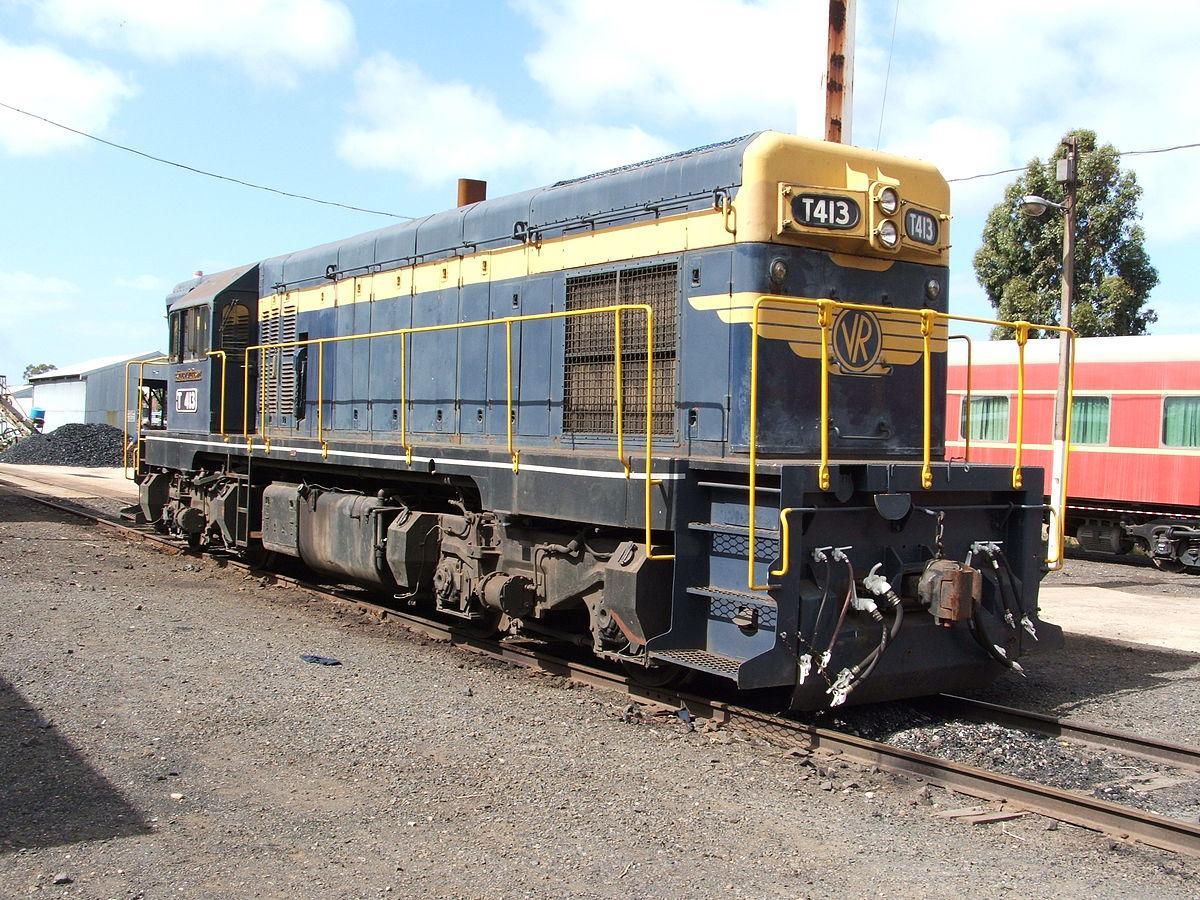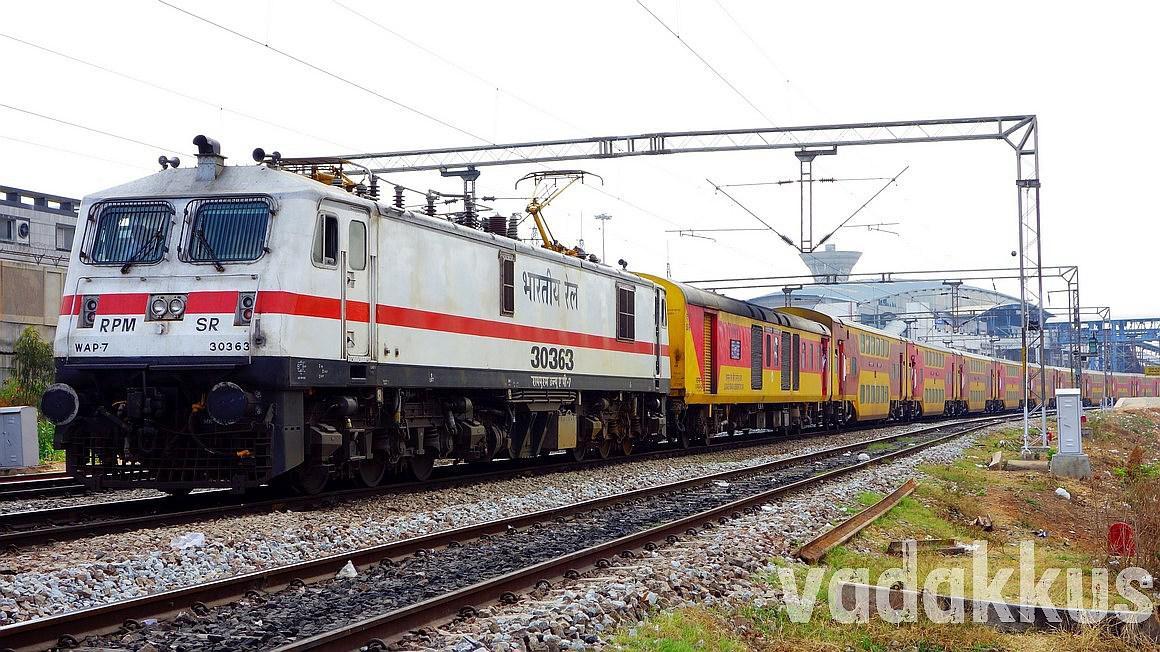The first image is the image on the left, the second image is the image on the right. For the images displayed, is the sentence "The engine in the image on the right is white with a red stripe on it." factually correct? Answer yes or no. Yes. The first image is the image on the left, the second image is the image on the right. Analyze the images presented: Is the assertion "One train is primarily white with at least one red stripe, and the other train is primarily red with a pale stripe." valid? Answer yes or no. No. 